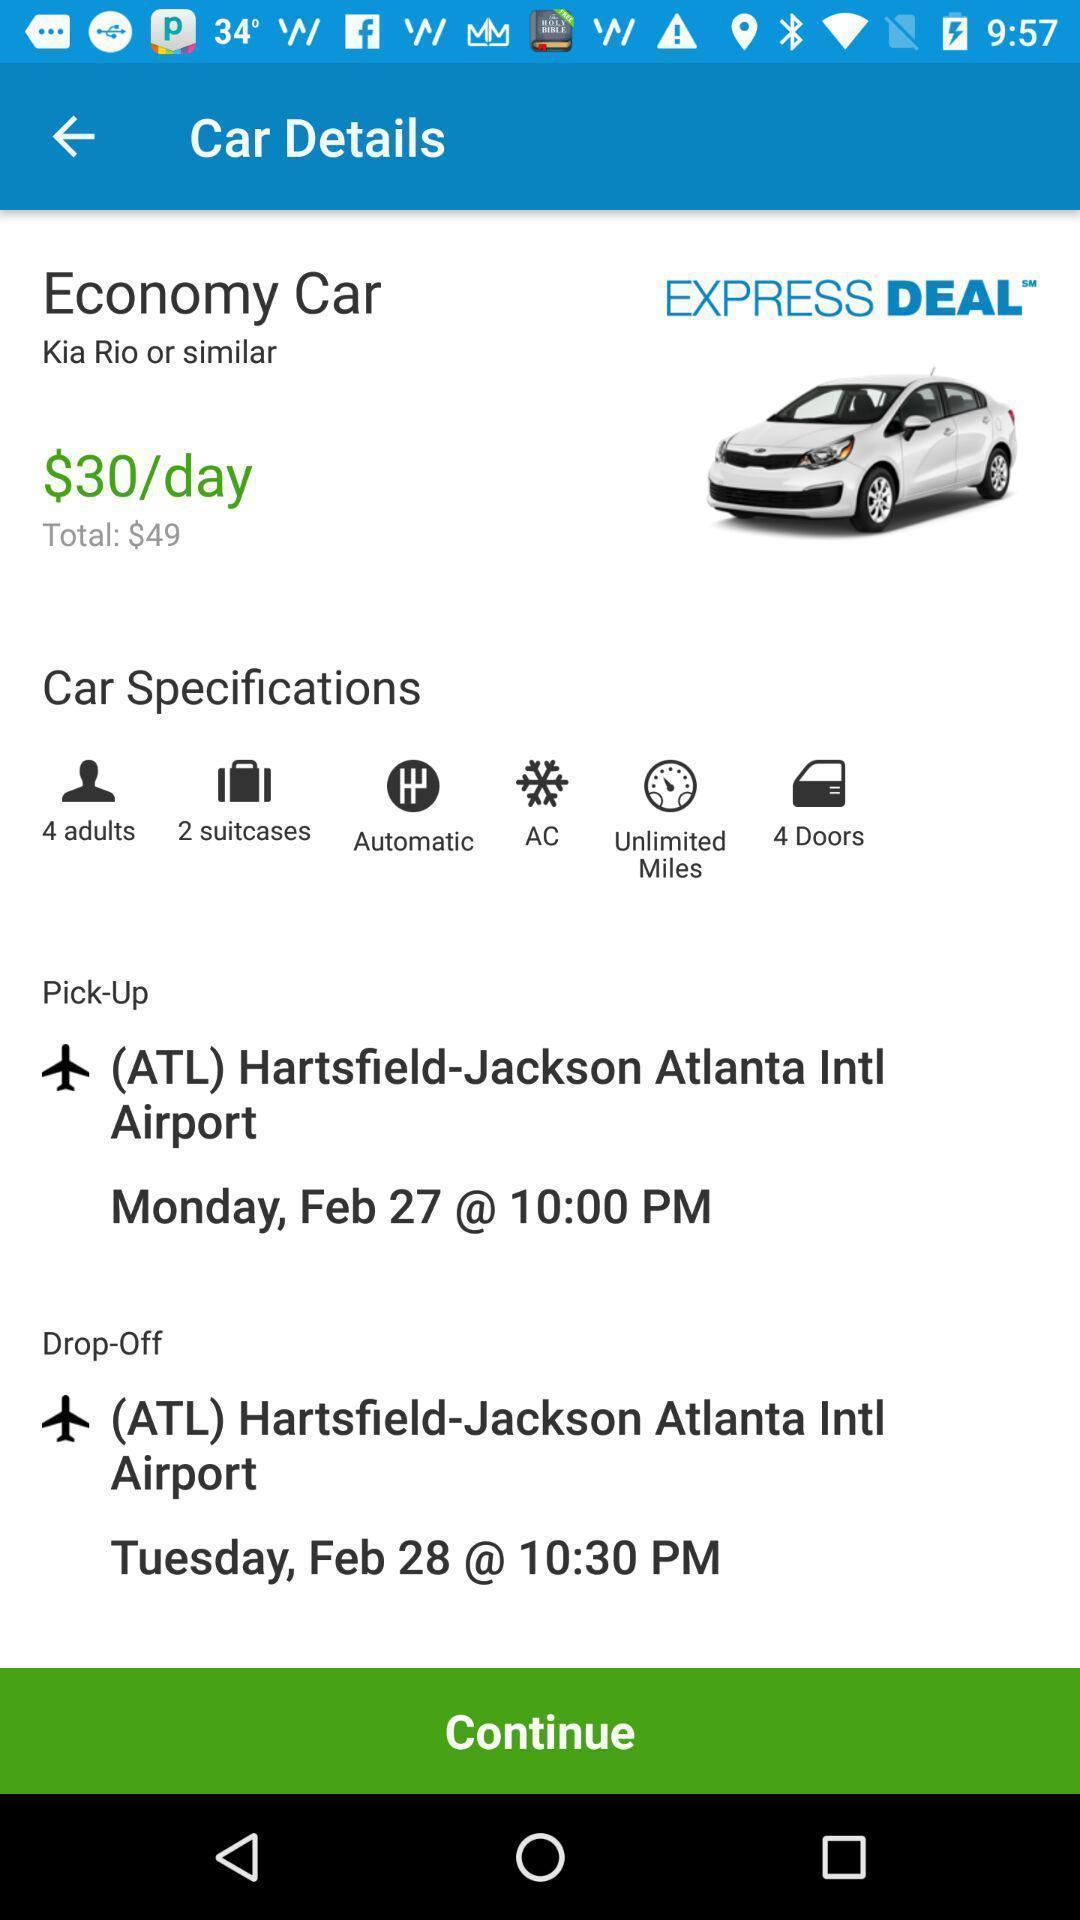Tell me what you see in this picture. Screen giving general specifications on car details. 